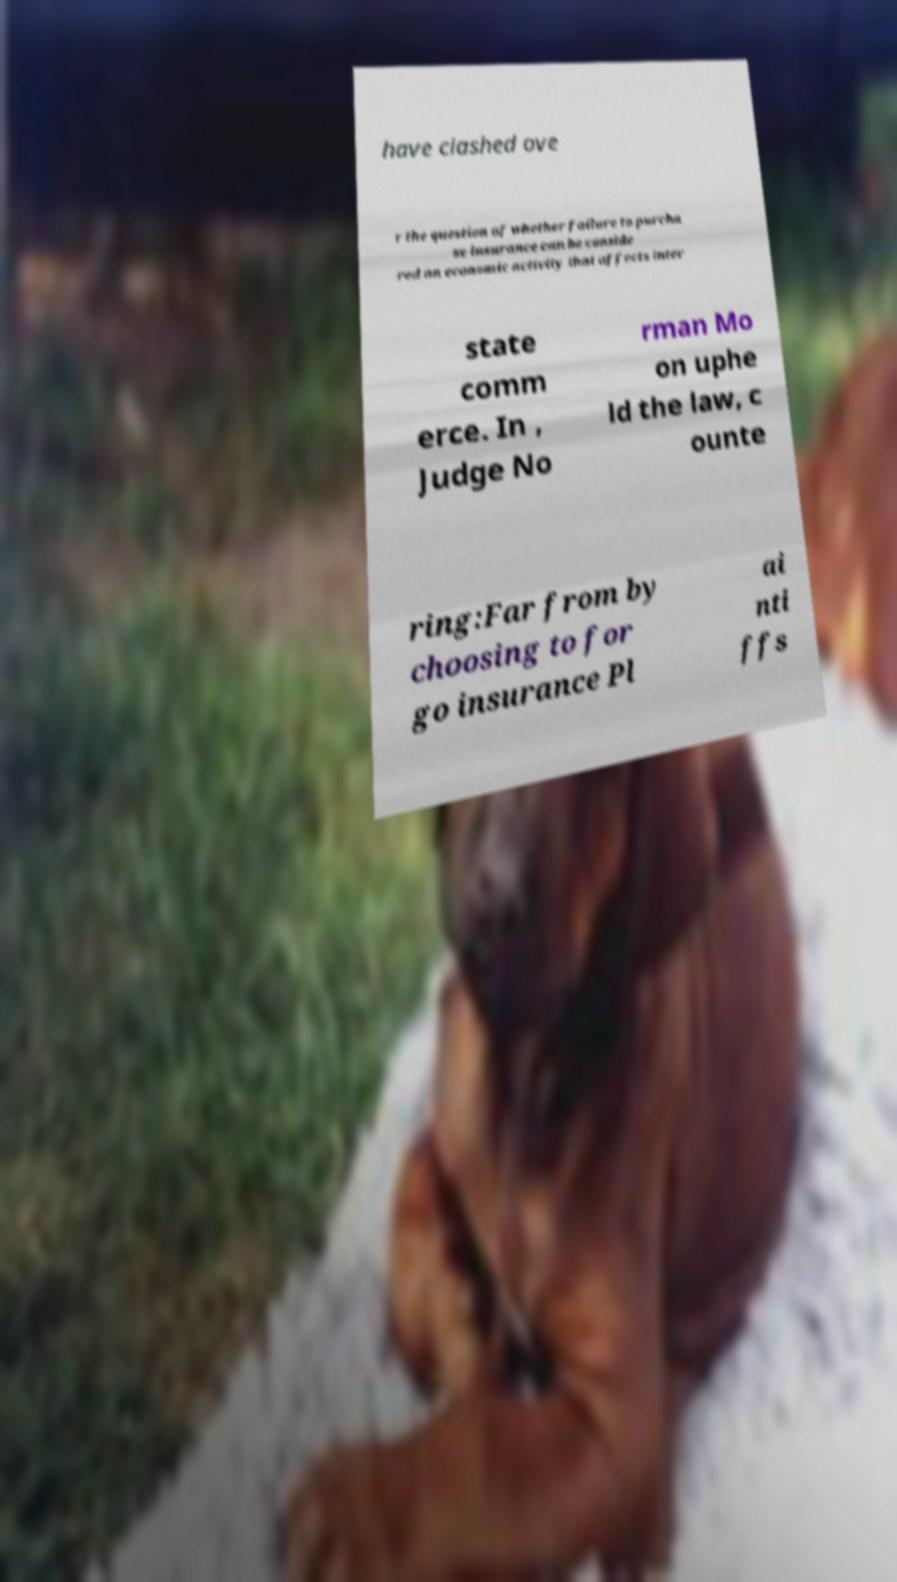I need the written content from this picture converted into text. Can you do that? have clashed ove r the question of whether failure to purcha se insurance can be conside red an economic activity that affects inter state comm erce. In , Judge No rman Mo on uphe ld the law, c ounte ring:Far from by choosing to for go insurance Pl ai nti ffs 